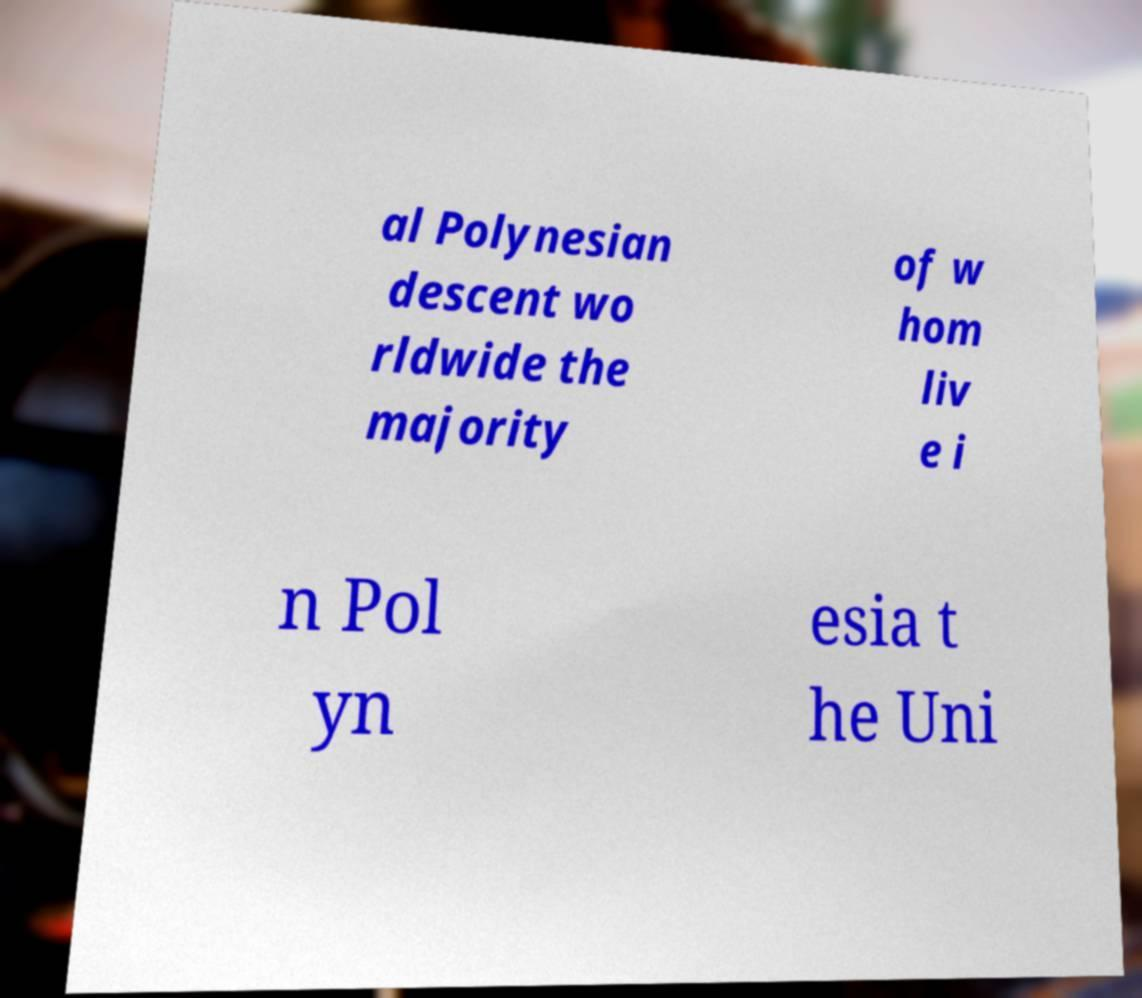Please read and relay the text visible in this image. What does it say? al Polynesian descent wo rldwide the majority of w hom liv e i n Pol yn esia t he Uni 